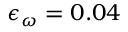<formula> <loc_0><loc_0><loc_500><loc_500>\epsilon _ { \omega } = 0 . 0 4</formula> 